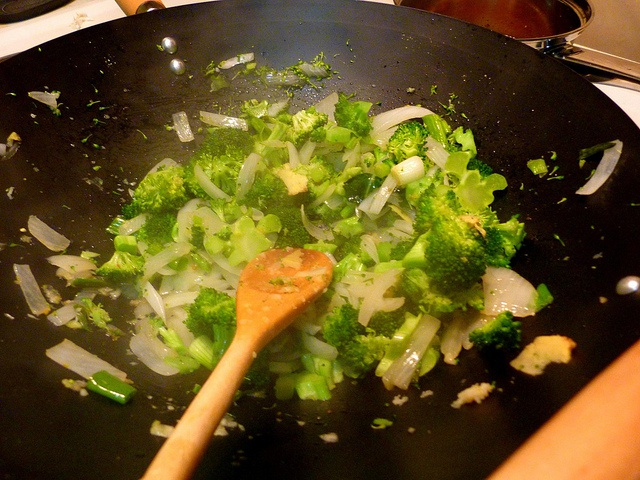Describe the objects in this image and their specific colors. I can see broccoli in black, darkgreen, and olive tones, broccoli in black, olive, and tan tones, spoon in black, orange, and brown tones, and broccoli in black, olive, and khaki tones in this image. 